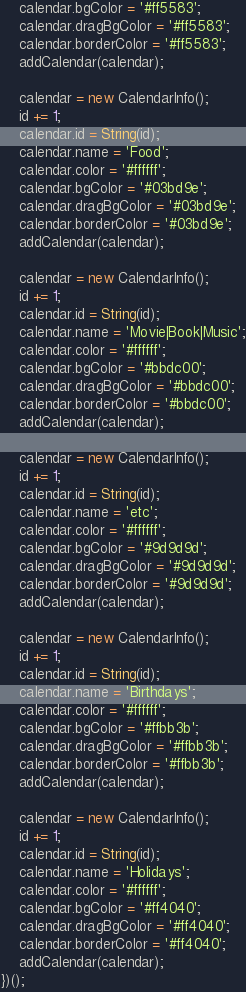Convert code to text. <code><loc_0><loc_0><loc_500><loc_500><_JavaScript_>    calendar.bgColor = '#ff5583';
    calendar.dragBgColor = '#ff5583';
    calendar.borderColor = '#ff5583';
    addCalendar(calendar);

    calendar = new CalendarInfo();
    id += 1;
    calendar.id = String(id);
    calendar.name = 'Food';
    calendar.color = '#ffffff';
    calendar.bgColor = '#03bd9e';
    calendar.dragBgColor = '#03bd9e';
    calendar.borderColor = '#03bd9e';
    addCalendar(calendar);

    calendar = new CalendarInfo();
    id += 1;
    calendar.id = String(id);
    calendar.name = 'Movie|Book|Music';
    calendar.color = '#ffffff';
    calendar.bgColor = '#bbdc00';
    calendar.dragBgColor = '#bbdc00';
    calendar.borderColor = '#bbdc00';
    addCalendar(calendar);

    calendar = new CalendarInfo();
    id += 1;
    calendar.id = String(id);
    calendar.name = 'etc';
    calendar.color = '#ffffff';
    calendar.bgColor = '#9d9d9d';
    calendar.dragBgColor = '#9d9d9d';
    calendar.borderColor = '#9d9d9d';
    addCalendar(calendar);

    calendar = new CalendarInfo();
    id += 1;
    calendar.id = String(id);
    calendar.name = 'Birthdays';
    calendar.color = '#ffffff';
    calendar.bgColor = '#ffbb3b';
    calendar.dragBgColor = '#ffbb3b';
    calendar.borderColor = '#ffbb3b';
    addCalendar(calendar);

    calendar = new CalendarInfo();
    id += 1;
    calendar.id = String(id);
    calendar.name = 'Holidays';
    calendar.color = '#ffffff';
    calendar.bgColor = '#ff4040';
    calendar.dragBgColor = '#ff4040';
    calendar.borderColor = '#ff4040';
    addCalendar(calendar);
})();
</code> 